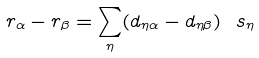<formula> <loc_0><loc_0><loc_500><loc_500>r _ { \alpha } - r _ { \beta } = \sum _ { \eta } ( d _ { \eta \alpha } - d _ { \eta \beta } ) \ s _ { \eta }</formula> 